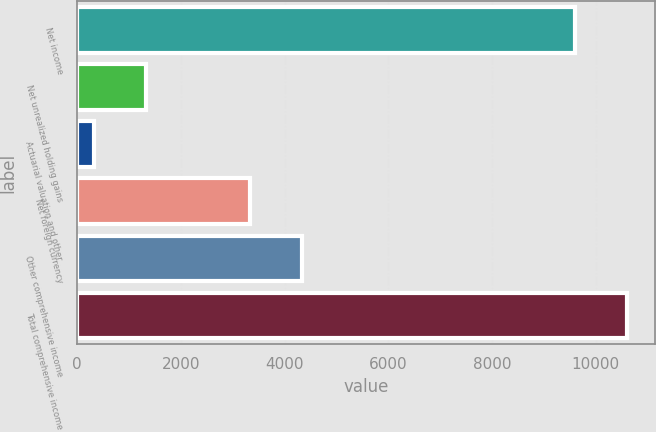Convert chart. <chart><loc_0><loc_0><loc_500><loc_500><bar_chart><fcel>Net income<fcel>Net unrealized holding gains<fcel>Actuarial valuation and other<fcel>Net foreign currency<fcel>Other comprehensive income<fcel>Total comprehensive income<nl><fcel>9601<fcel>1321<fcel>317<fcel>3329<fcel>4333<fcel>10605<nl></chart> 